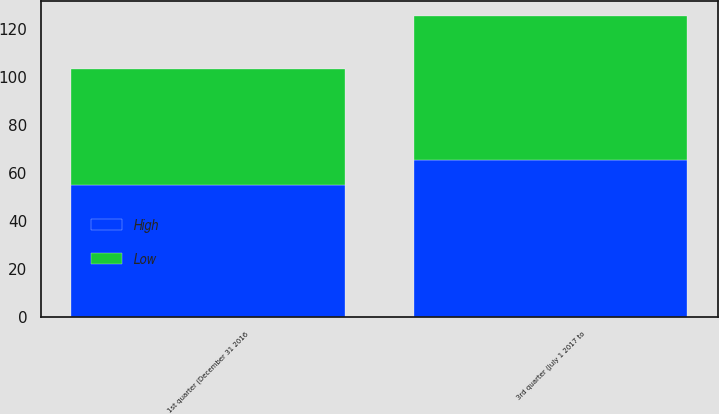Convert chart to OTSL. <chart><loc_0><loc_0><loc_500><loc_500><stacked_bar_chart><ecel><fcel>1st quarter (December 31 2016<fcel>3rd quarter (July 1 2017 to<nl><fcel>High<fcel>54.87<fcel>65.22<nl><fcel>Low<fcel>48.31<fcel>59.92<nl></chart> 